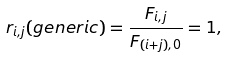<formula> <loc_0><loc_0><loc_500><loc_500>r _ { i , j } ( g e n e r i c ) = \frac { F _ { i , j } } { F _ { ( i + j ) , 0 } } = 1 ,</formula> 